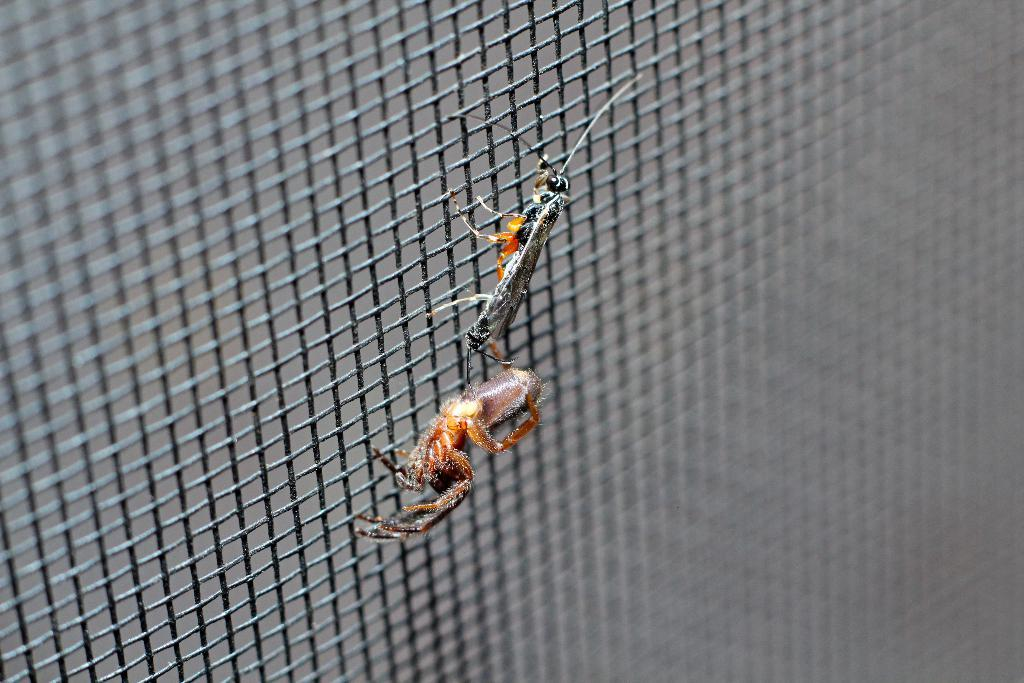How many insects are present in the image? There are two insects in the image. Where are the insects located in the image? The insects are on a grill. What type of trees can be seen in the image? There are no trees present in the image; it only features two insects on a grill. How does the quiver appear in the image? There is no quiver present in the image. 